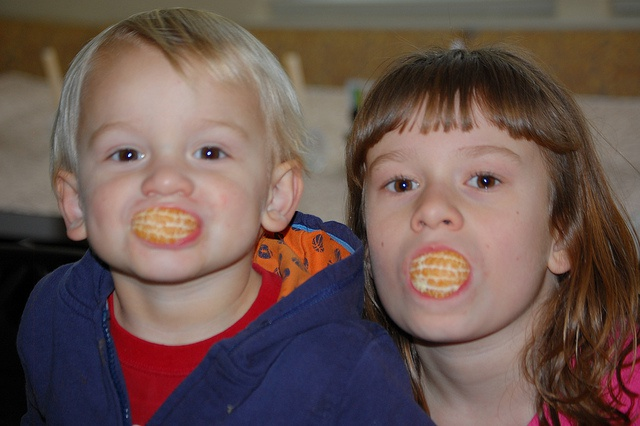Describe the objects in this image and their specific colors. I can see people in black, navy, darkgray, and gray tones, people in black, gray, darkgray, and maroon tones, orange in black, tan, and salmon tones, and orange in black, tan, and salmon tones in this image. 